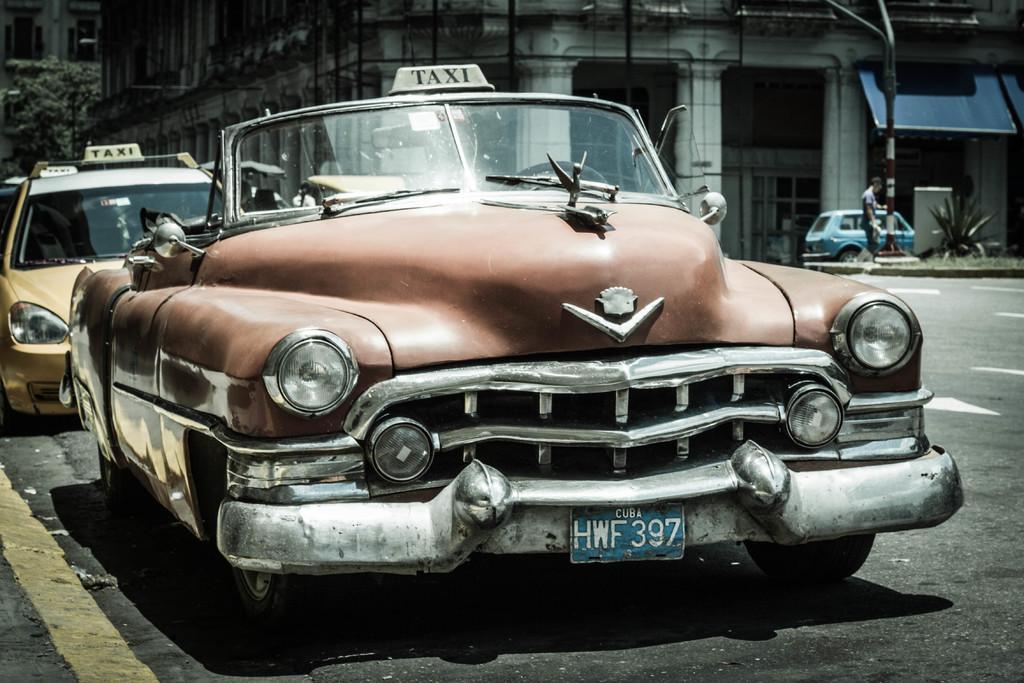Describe this image in one or two sentences. In this image there are cars parked on the road. In the background of the image there are plants, buildings, trees. 